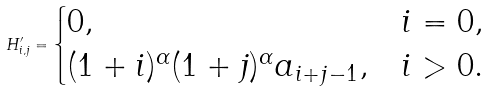Convert formula to latex. <formula><loc_0><loc_0><loc_500><loc_500>H _ { i , j } ^ { \prime } = \begin{cases} 0 , & i = 0 , \\ ( 1 + i ) ^ { \alpha } ( 1 + j ) ^ { \alpha } a _ { i + j - 1 } , & i > 0 . \end{cases}</formula> 